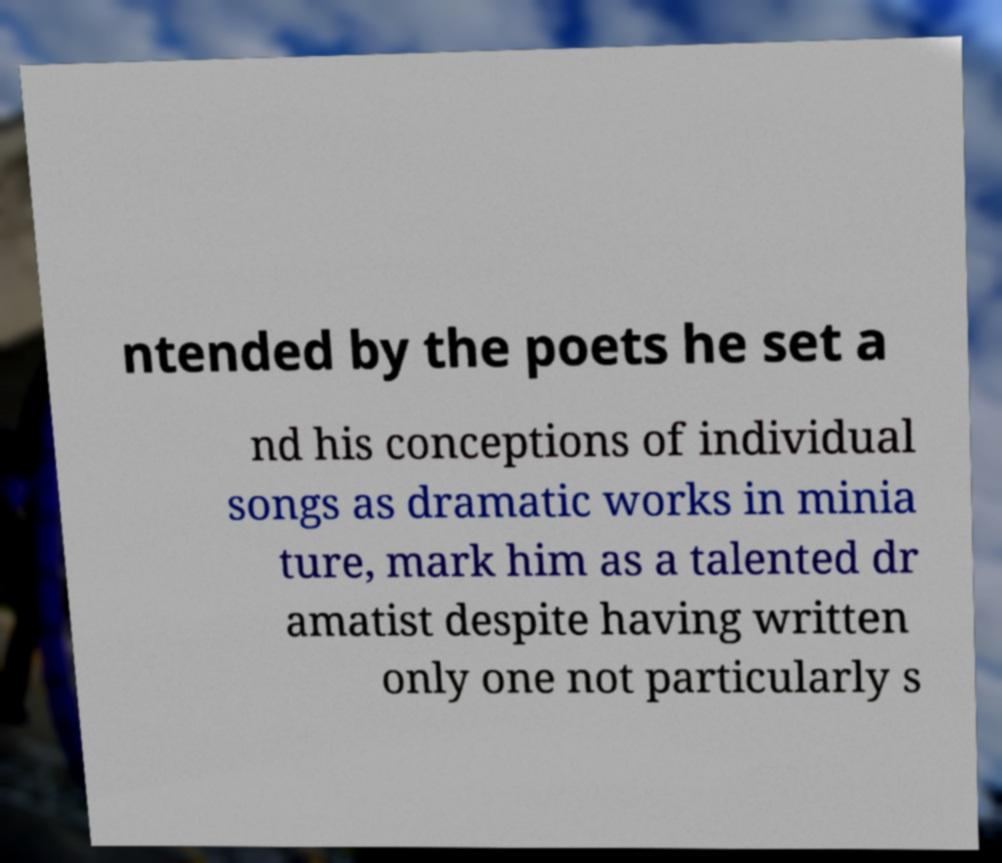Please identify and transcribe the text found in this image. ntended by the poets he set a nd his conceptions of individual songs as dramatic works in minia ture, mark him as a talented dr amatist despite having written only one not particularly s 